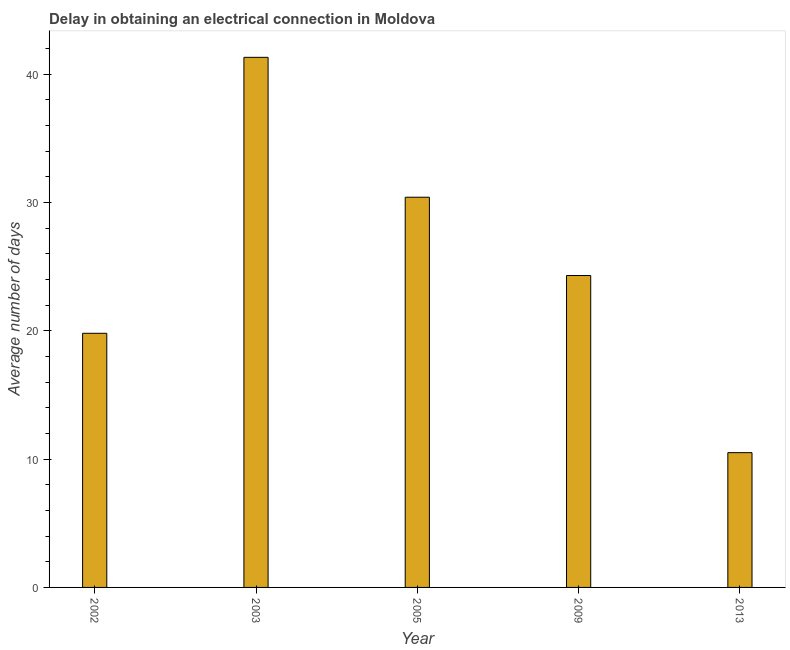Does the graph contain grids?
Offer a very short reply. No. What is the title of the graph?
Make the answer very short. Delay in obtaining an electrical connection in Moldova. What is the label or title of the X-axis?
Make the answer very short. Year. What is the label or title of the Y-axis?
Your answer should be very brief. Average number of days. What is the dalay in electrical connection in 2005?
Your answer should be compact. 30.4. Across all years, what is the maximum dalay in electrical connection?
Make the answer very short. 41.3. In which year was the dalay in electrical connection minimum?
Make the answer very short. 2013. What is the sum of the dalay in electrical connection?
Offer a terse response. 126.3. What is the difference between the dalay in electrical connection in 2009 and 2013?
Ensure brevity in your answer.  13.8. What is the average dalay in electrical connection per year?
Your answer should be compact. 25.26. What is the median dalay in electrical connection?
Your answer should be very brief. 24.3. Do a majority of the years between 2009 and 2013 (inclusive) have dalay in electrical connection greater than 40 days?
Your response must be concise. No. What is the ratio of the dalay in electrical connection in 2009 to that in 2013?
Your response must be concise. 2.31. Is the difference between the dalay in electrical connection in 2002 and 2003 greater than the difference between any two years?
Provide a succinct answer. No. What is the difference between the highest and the second highest dalay in electrical connection?
Your answer should be compact. 10.9. What is the difference between the highest and the lowest dalay in electrical connection?
Provide a short and direct response. 30.8. In how many years, is the dalay in electrical connection greater than the average dalay in electrical connection taken over all years?
Your response must be concise. 2. How many bars are there?
Your answer should be very brief. 5. How many years are there in the graph?
Provide a short and direct response. 5. Are the values on the major ticks of Y-axis written in scientific E-notation?
Your answer should be very brief. No. What is the Average number of days in 2002?
Give a very brief answer. 19.8. What is the Average number of days in 2003?
Your response must be concise. 41.3. What is the Average number of days of 2005?
Provide a succinct answer. 30.4. What is the Average number of days in 2009?
Provide a short and direct response. 24.3. What is the difference between the Average number of days in 2002 and 2003?
Offer a terse response. -21.5. What is the difference between the Average number of days in 2002 and 2009?
Offer a very short reply. -4.5. What is the difference between the Average number of days in 2002 and 2013?
Your answer should be very brief. 9.3. What is the difference between the Average number of days in 2003 and 2005?
Your response must be concise. 10.9. What is the difference between the Average number of days in 2003 and 2013?
Make the answer very short. 30.8. What is the difference between the Average number of days in 2005 and 2013?
Your answer should be compact. 19.9. What is the ratio of the Average number of days in 2002 to that in 2003?
Keep it short and to the point. 0.48. What is the ratio of the Average number of days in 2002 to that in 2005?
Provide a short and direct response. 0.65. What is the ratio of the Average number of days in 2002 to that in 2009?
Offer a very short reply. 0.81. What is the ratio of the Average number of days in 2002 to that in 2013?
Ensure brevity in your answer.  1.89. What is the ratio of the Average number of days in 2003 to that in 2005?
Keep it short and to the point. 1.36. What is the ratio of the Average number of days in 2003 to that in 2013?
Your answer should be compact. 3.93. What is the ratio of the Average number of days in 2005 to that in 2009?
Provide a short and direct response. 1.25. What is the ratio of the Average number of days in 2005 to that in 2013?
Offer a terse response. 2.9. What is the ratio of the Average number of days in 2009 to that in 2013?
Provide a short and direct response. 2.31. 